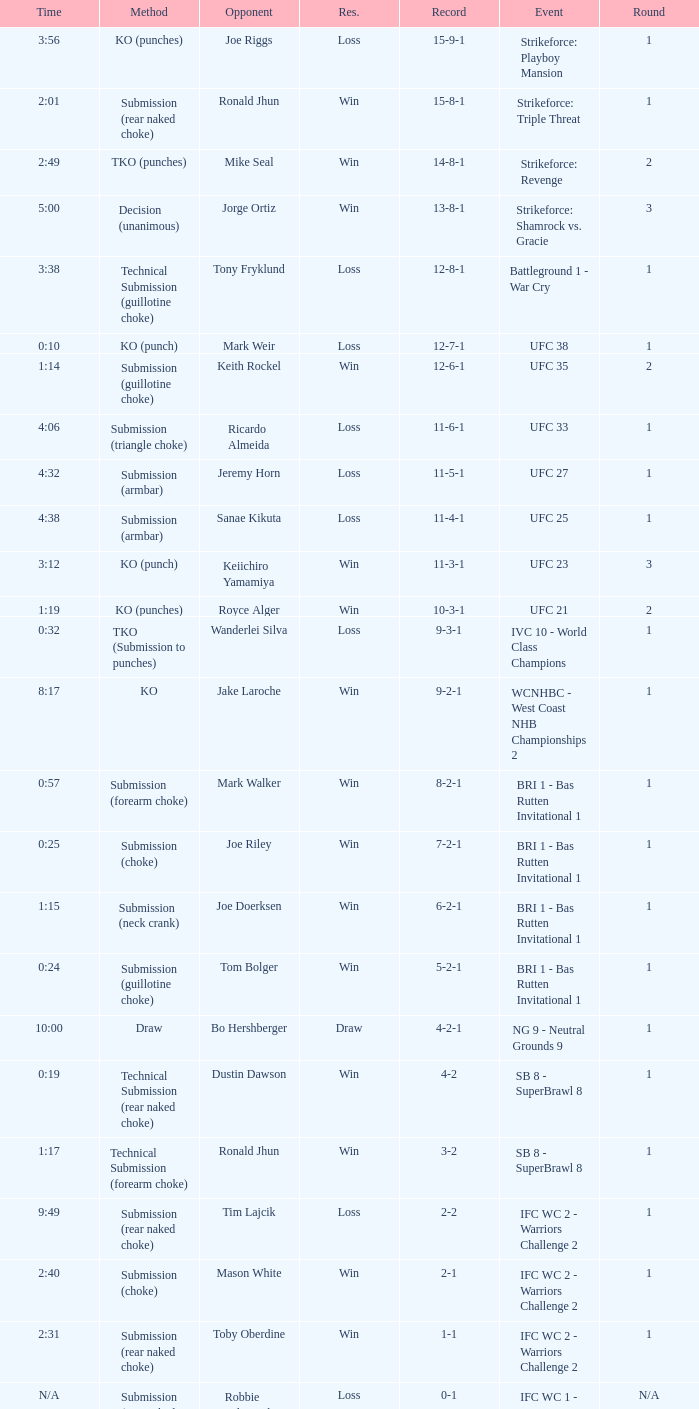What was the resolution for the fight against tom bolger by submission (guillotine choke)? Win. 